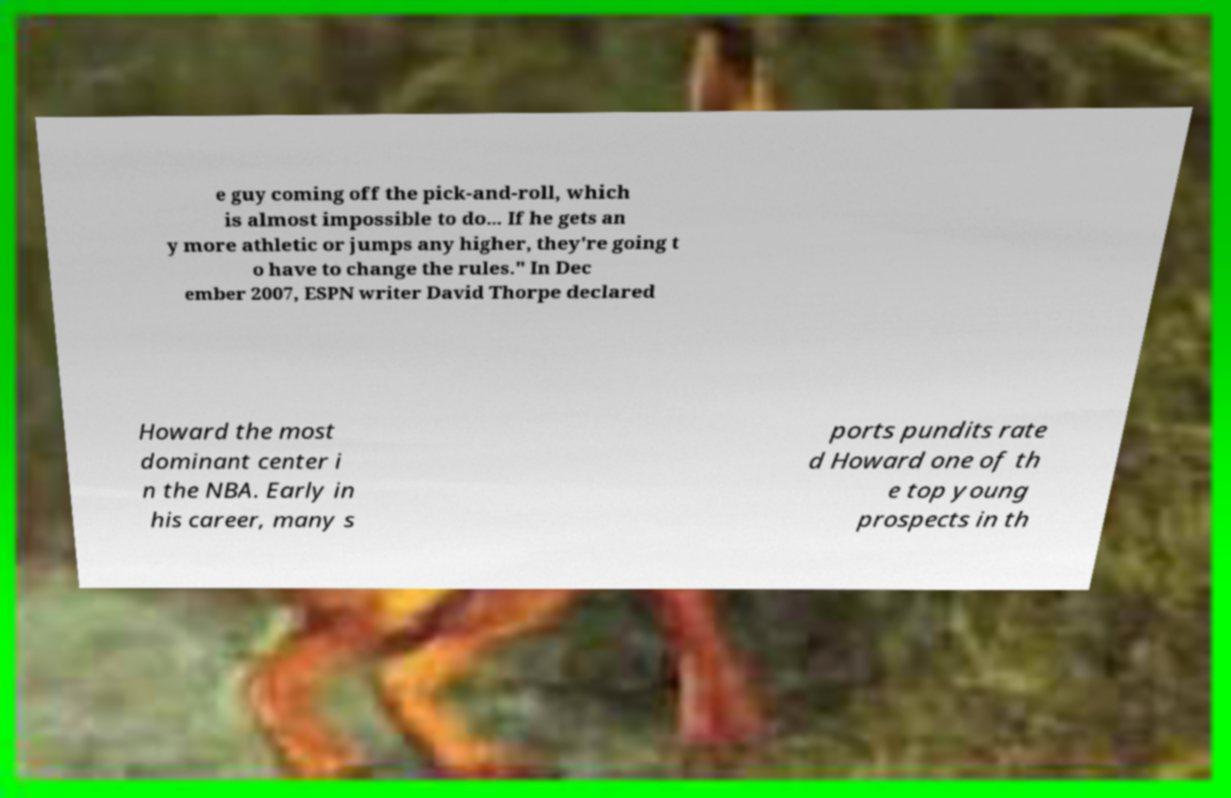For documentation purposes, I need the text within this image transcribed. Could you provide that? e guy coming off the pick-and-roll, which is almost impossible to do... If he gets an y more athletic or jumps any higher, they're going t o have to change the rules." In Dec ember 2007, ESPN writer David Thorpe declared Howard the most dominant center i n the NBA. Early in his career, many s ports pundits rate d Howard one of th e top young prospects in th 